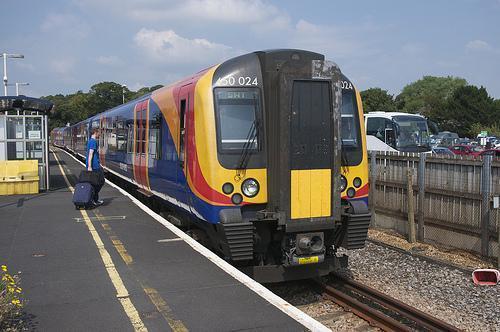How many people are shown?
Give a very brief answer. 1. 